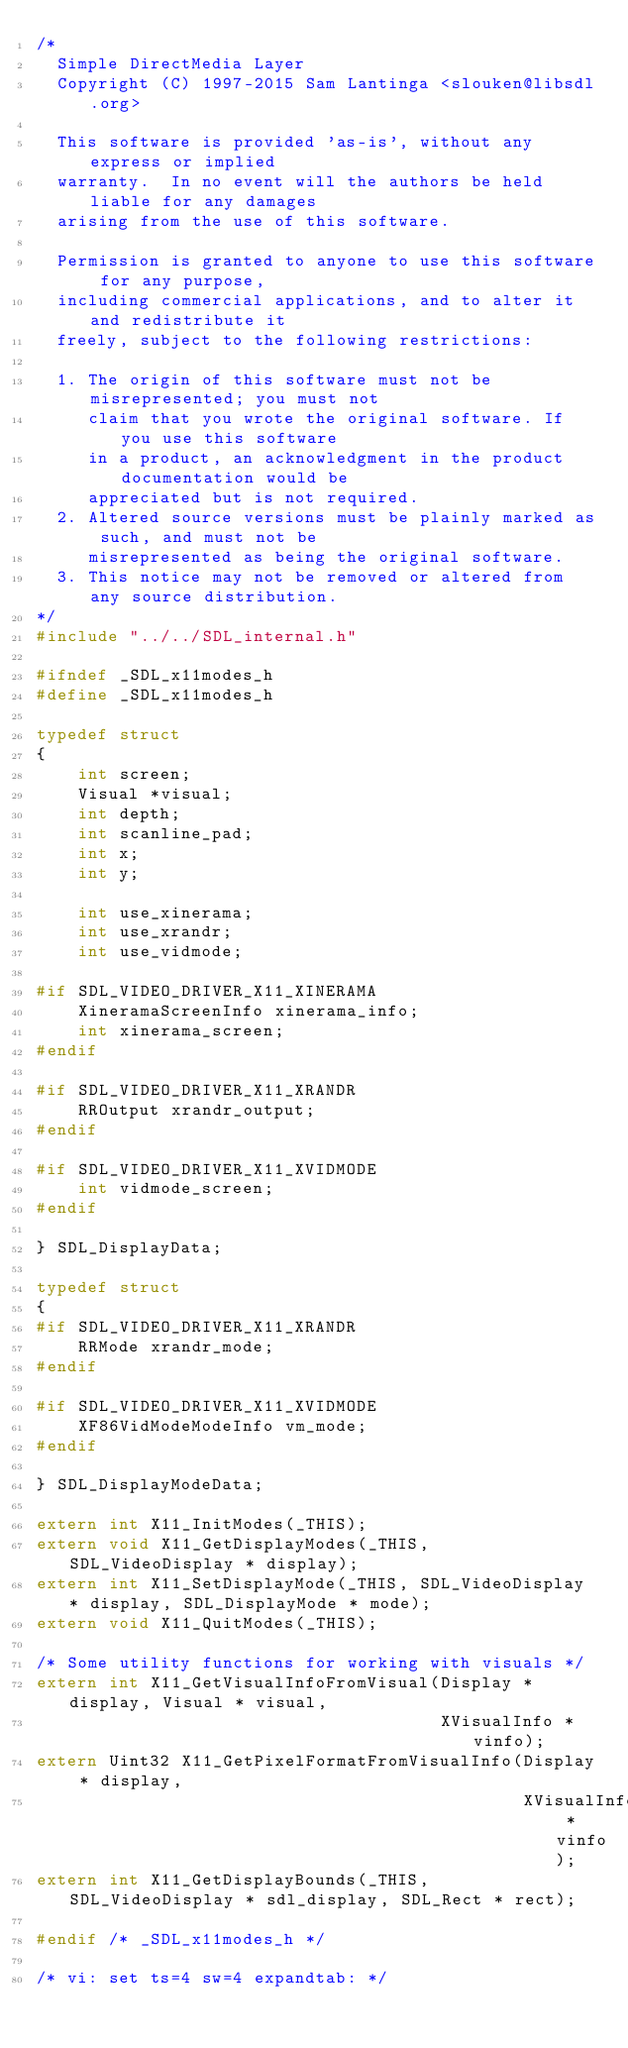Convert code to text. <code><loc_0><loc_0><loc_500><loc_500><_C_>/*
  Simple DirectMedia Layer
  Copyright (C) 1997-2015 Sam Lantinga <slouken@libsdl.org>

  This software is provided 'as-is', without any express or implied
  warranty.  In no event will the authors be held liable for any damages
  arising from the use of this software.

  Permission is granted to anyone to use this software for any purpose,
  including commercial applications, and to alter it and redistribute it
  freely, subject to the following restrictions:

  1. The origin of this software must not be misrepresented; you must not
     claim that you wrote the original software. If you use this software
     in a product, an acknowledgment in the product documentation would be
     appreciated but is not required.
  2. Altered source versions must be plainly marked as such, and must not be
     misrepresented as being the original software.
  3. This notice may not be removed or altered from any source distribution.
*/
#include "../../SDL_internal.h"

#ifndef _SDL_x11modes_h
#define _SDL_x11modes_h

typedef struct
{
    int screen;
    Visual *visual;
    int depth;
    int scanline_pad;
    int x;
    int y;

    int use_xinerama;
    int use_xrandr;
    int use_vidmode;

#if SDL_VIDEO_DRIVER_X11_XINERAMA
    XineramaScreenInfo xinerama_info;
    int xinerama_screen;
#endif

#if SDL_VIDEO_DRIVER_X11_XRANDR
    RROutput xrandr_output;
#endif

#if SDL_VIDEO_DRIVER_X11_XVIDMODE
    int vidmode_screen;
#endif

} SDL_DisplayData;

typedef struct
{
#if SDL_VIDEO_DRIVER_X11_XRANDR
    RRMode xrandr_mode;
#endif

#if SDL_VIDEO_DRIVER_X11_XVIDMODE
    XF86VidModeModeInfo vm_mode;
#endif

} SDL_DisplayModeData;

extern int X11_InitModes(_THIS);
extern void X11_GetDisplayModes(_THIS, SDL_VideoDisplay * display);
extern int X11_SetDisplayMode(_THIS, SDL_VideoDisplay * display, SDL_DisplayMode * mode);
extern void X11_QuitModes(_THIS);

/* Some utility functions for working with visuals */
extern int X11_GetVisualInfoFromVisual(Display * display, Visual * visual,
                                       XVisualInfo * vinfo);
extern Uint32 X11_GetPixelFormatFromVisualInfo(Display * display,
                                               XVisualInfo * vinfo);
extern int X11_GetDisplayBounds(_THIS, SDL_VideoDisplay * sdl_display, SDL_Rect * rect);

#endif /* _SDL_x11modes_h */

/* vi: set ts=4 sw=4 expandtab: */
</code> 